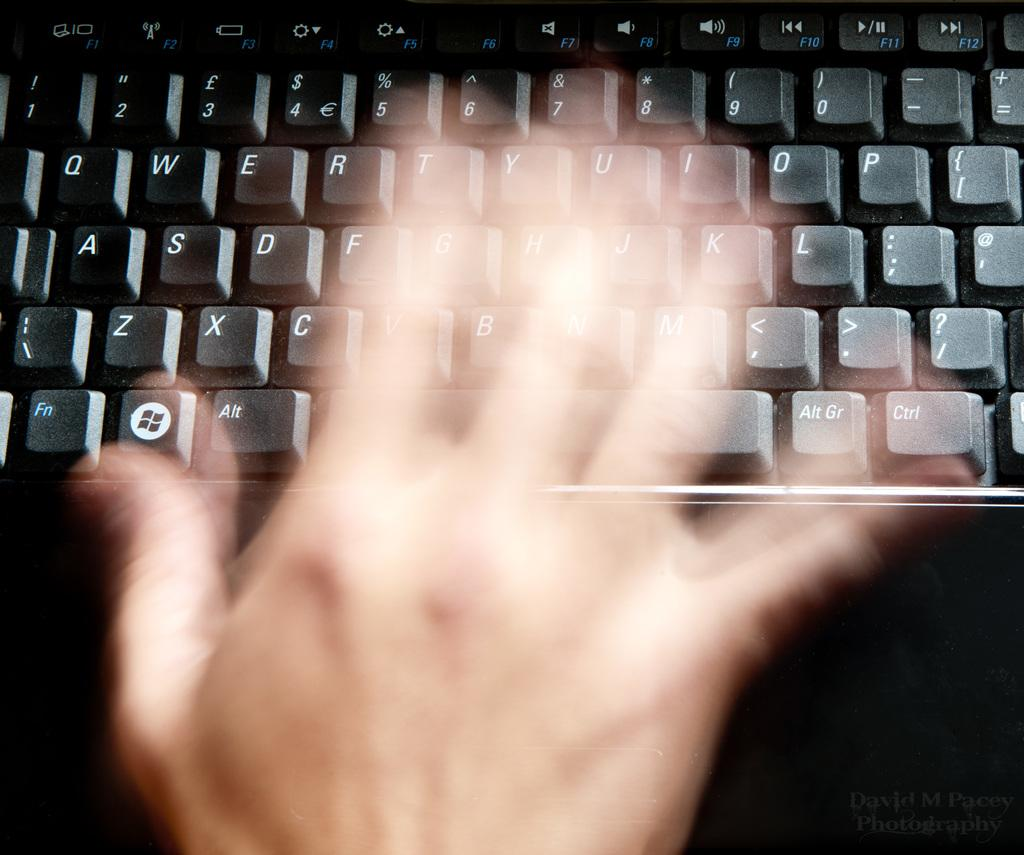<image>
Provide a brief description of the given image. A computer keyboard with the function key visible at the bottom left. 